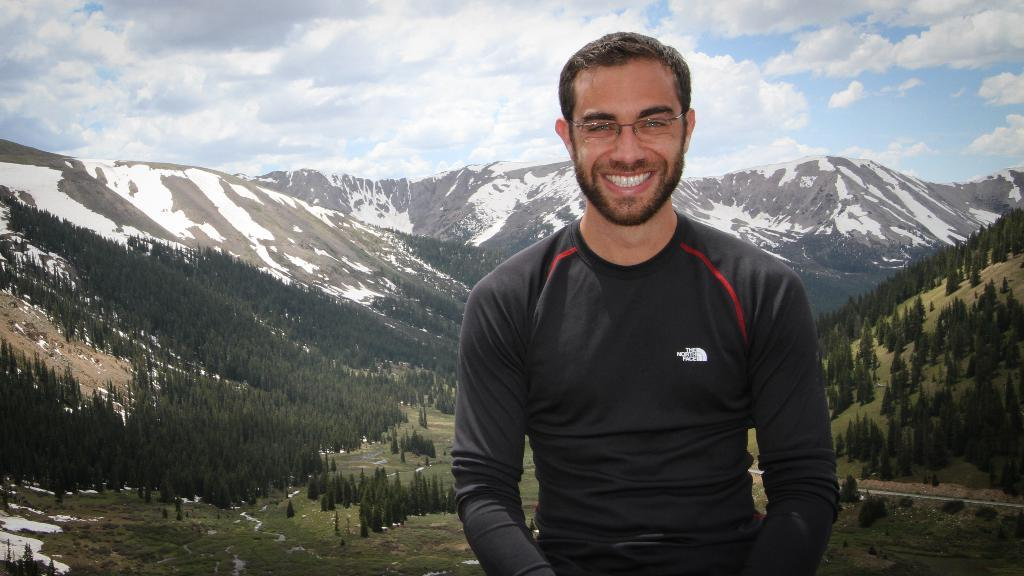Who is present in the image? There is a man in the image. What is the man doing in the image? The man is smiling in the image. What is the man wearing in the image? The man is wearing a black t-shirt in the image. What can be seen in the background of the image? There are mountains, trees, and grasslands in the background of the image. What is the condition of the sky in the image? The sky is blue with clouds in the image. What type of trouble is the man causing in the image? There is no indication of trouble or any negative actions in the image; the man is simply smiling. What kind of shade is provided by the trees in the image? There are no people or objects in the image that would require shade from the trees; the trees are part of the background scenery. 